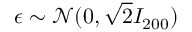<formula> <loc_0><loc_0><loc_500><loc_500>\epsilon \sim \mathcal { N } ( 0 , \sqrt { 2 } I _ { 2 0 0 } )</formula> 